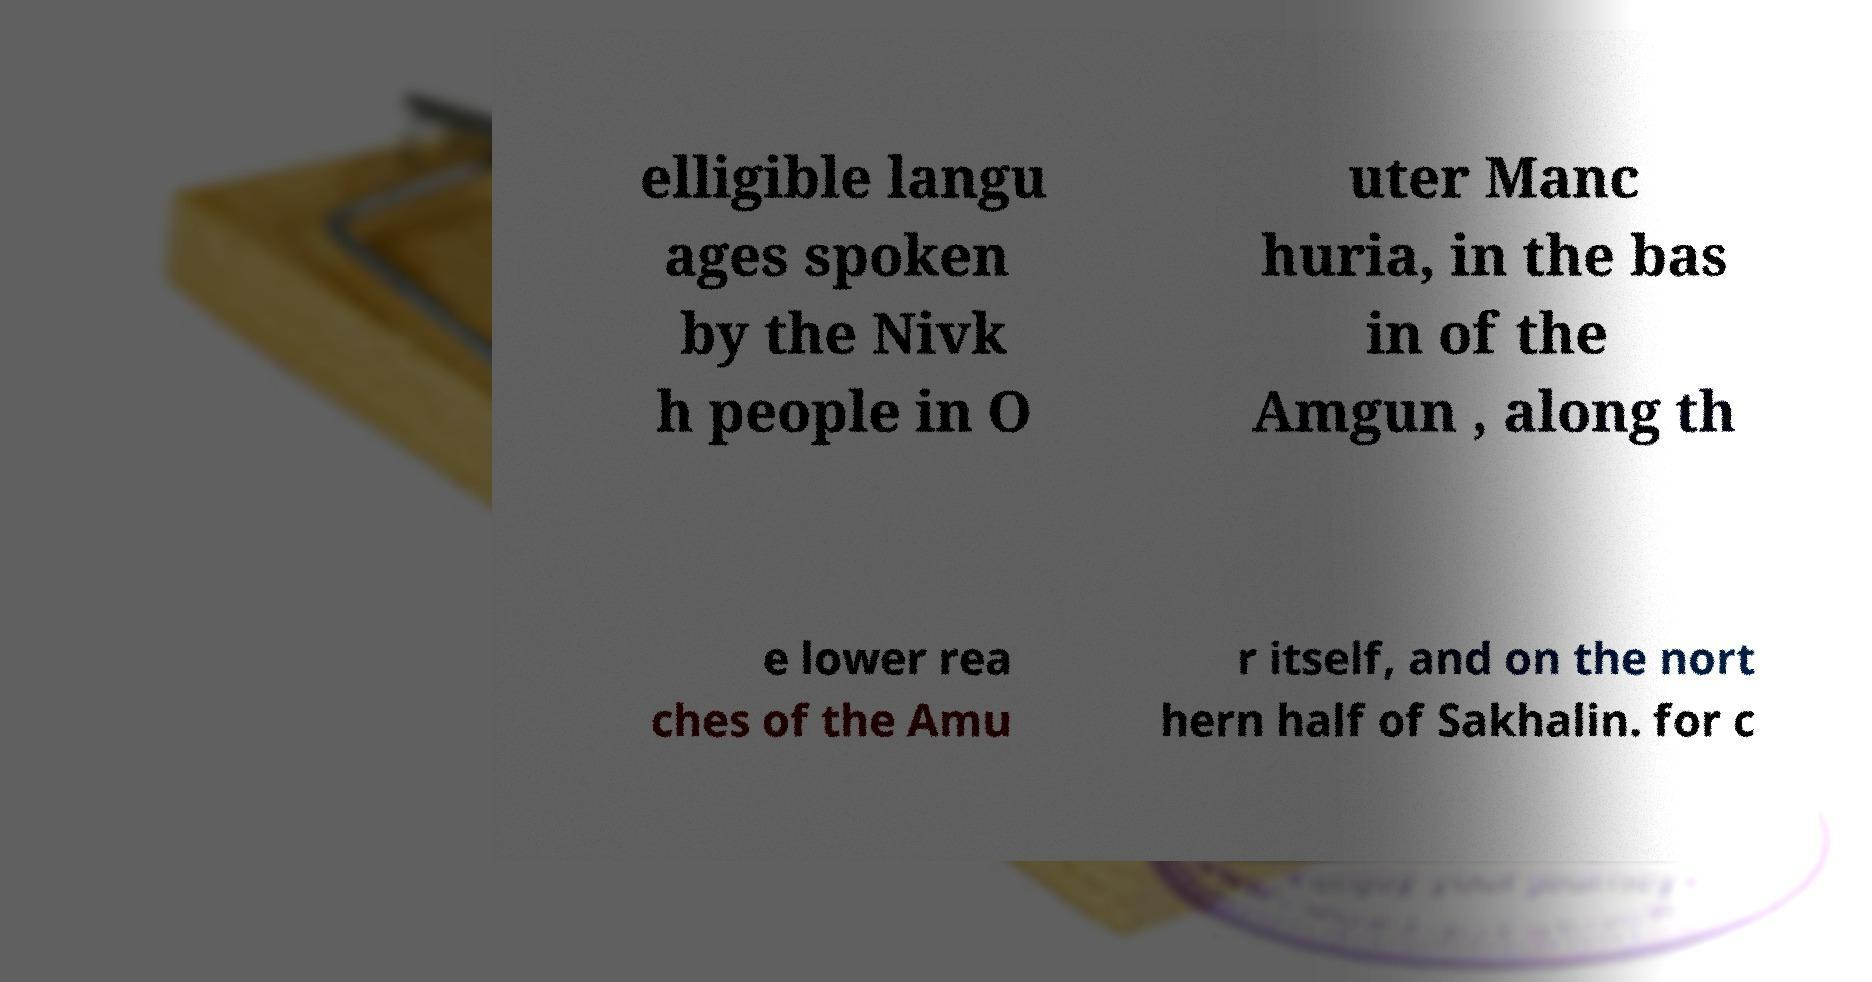There's text embedded in this image that I need extracted. Can you transcribe it verbatim? elligible langu ages spoken by the Nivk h people in O uter Manc huria, in the bas in of the Amgun , along th e lower rea ches of the Amu r itself, and on the nort hern half of Sakhalin. for c 